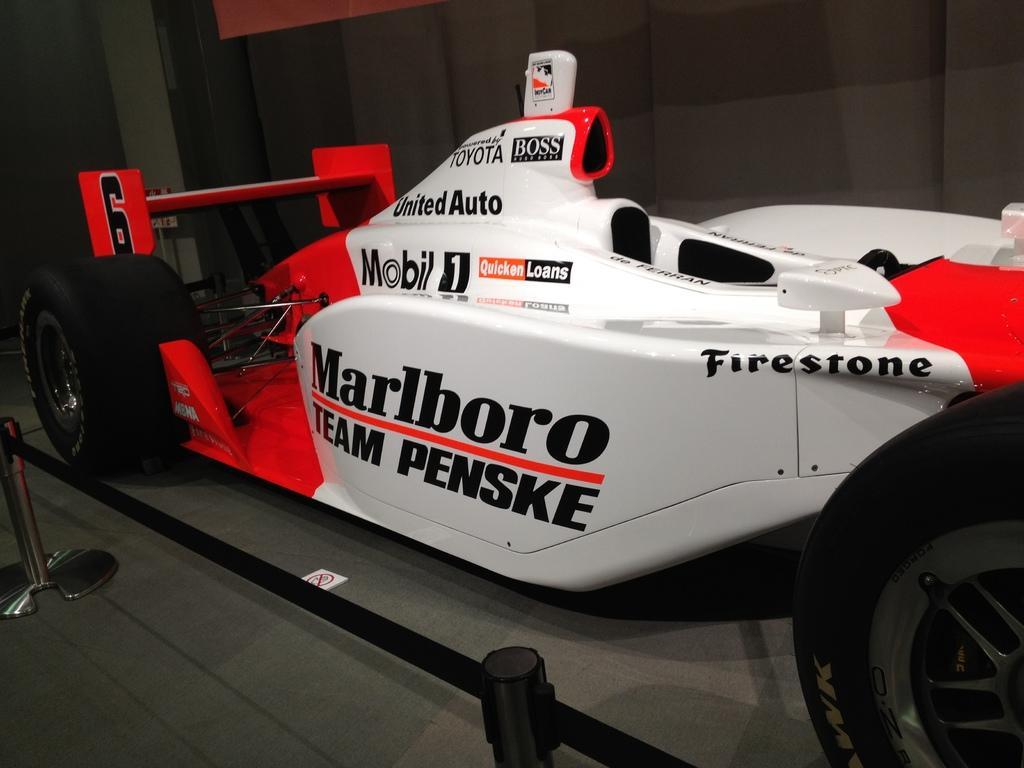Describe this image in one or two sentences. In this image, we can see a vehicle is parked on the floor. At the bottom, we can see rods and ropes. Here there is a sign board on the floor. Background we can see curtain, object and wall. 